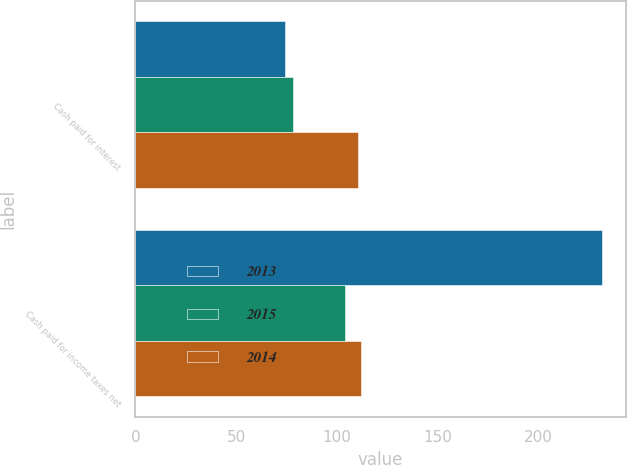Convert chart to OTSL. <chart><loc_0><loc_0><loc_500><loc_500><stacked_bar_chart><ecel><fcel>Cash paid for interest<fcel>Cash paid for income taxes net<nl><fcel>2013<fcel>74.5<fcel>231.9<nl><fcel>2015<fcel>78.1<fcel>103.9<nl><fcel>2014<fcel>110.7<fcel>111.8<nl></chart> 